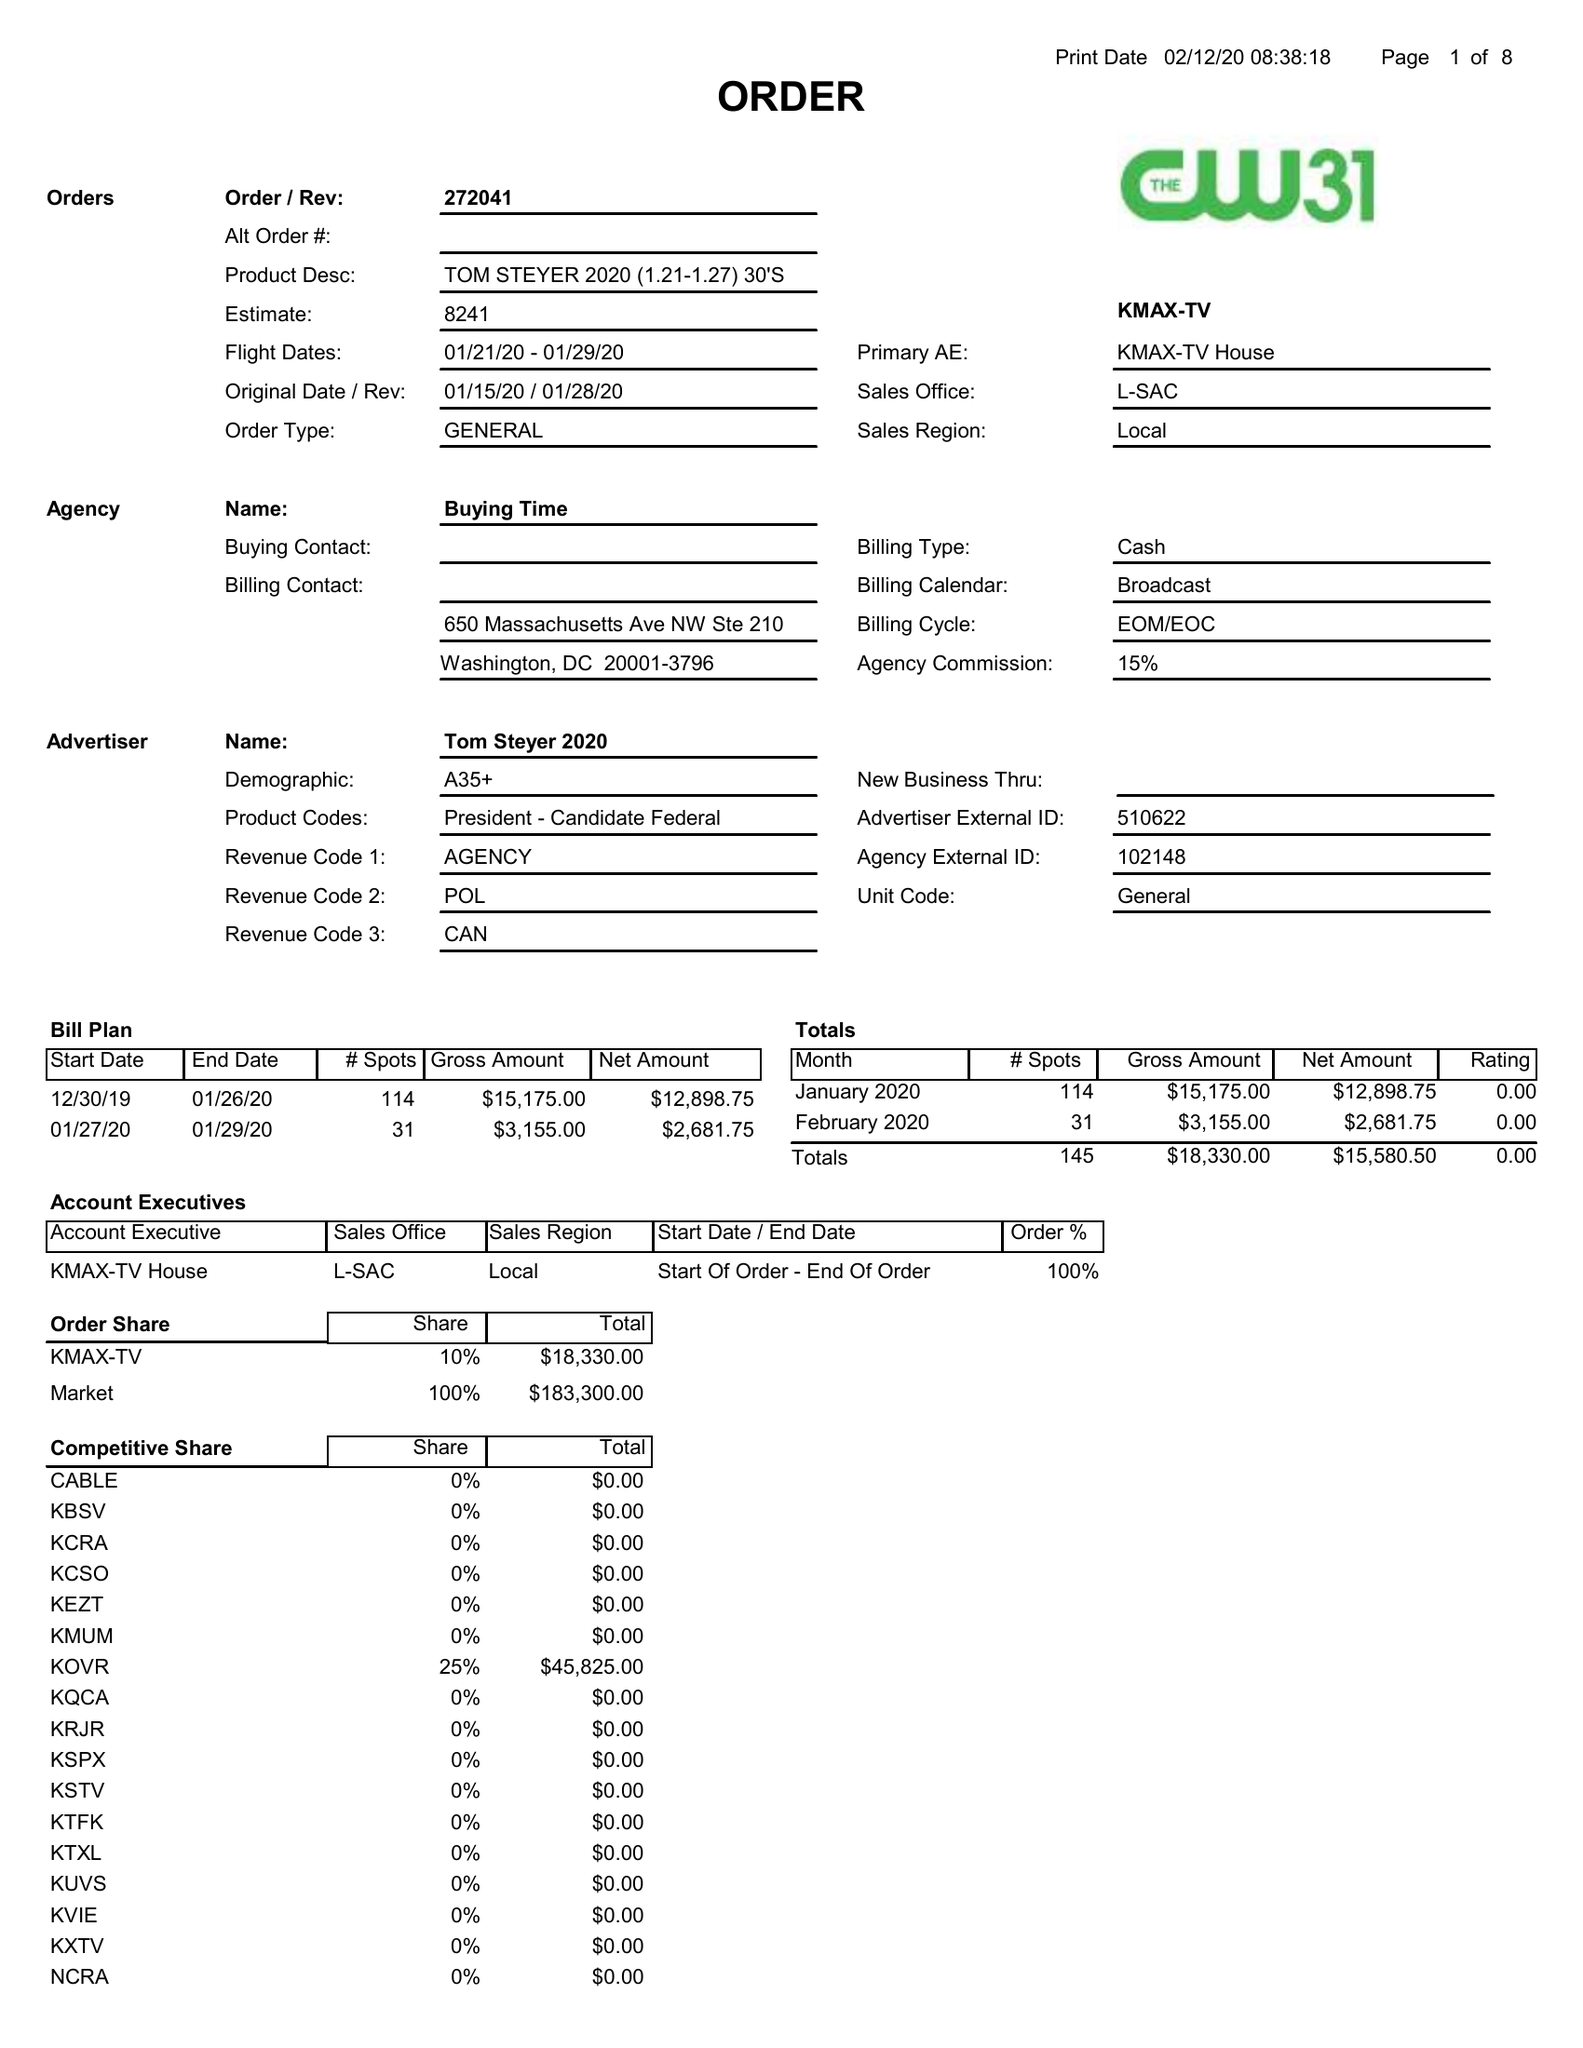What is the value for the advertiser?
Answer the question using a single word or phrase. TOM STEYER 2020 